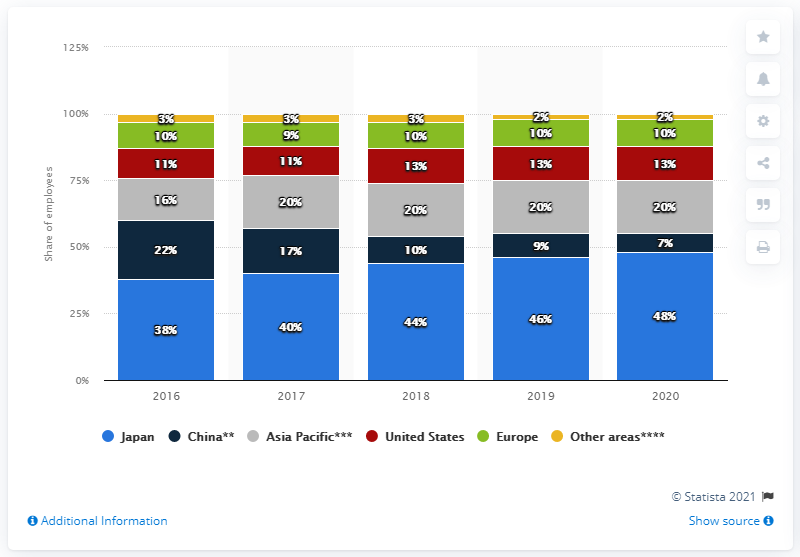Highlight a few significant elements in this photo. In the financial year 2020, 48% of Sony's employees were located in Japan. 